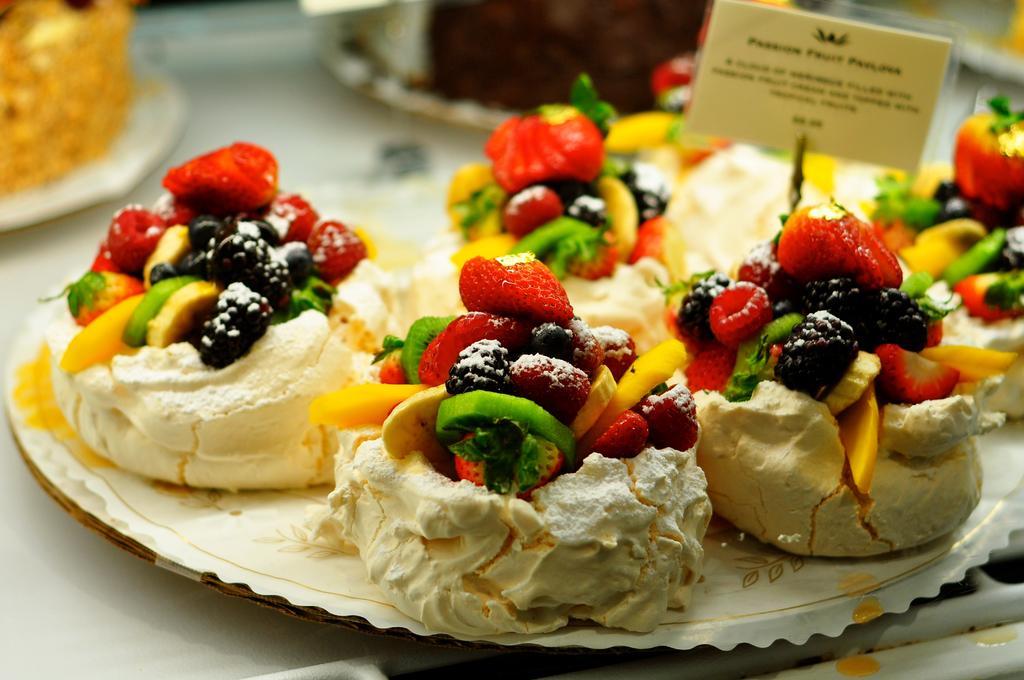Could you give a brief overview of what you see in this image? In this image we can see food items in plates. There is a paper with some text on it. At the bottom of the image there is a white color surface. 